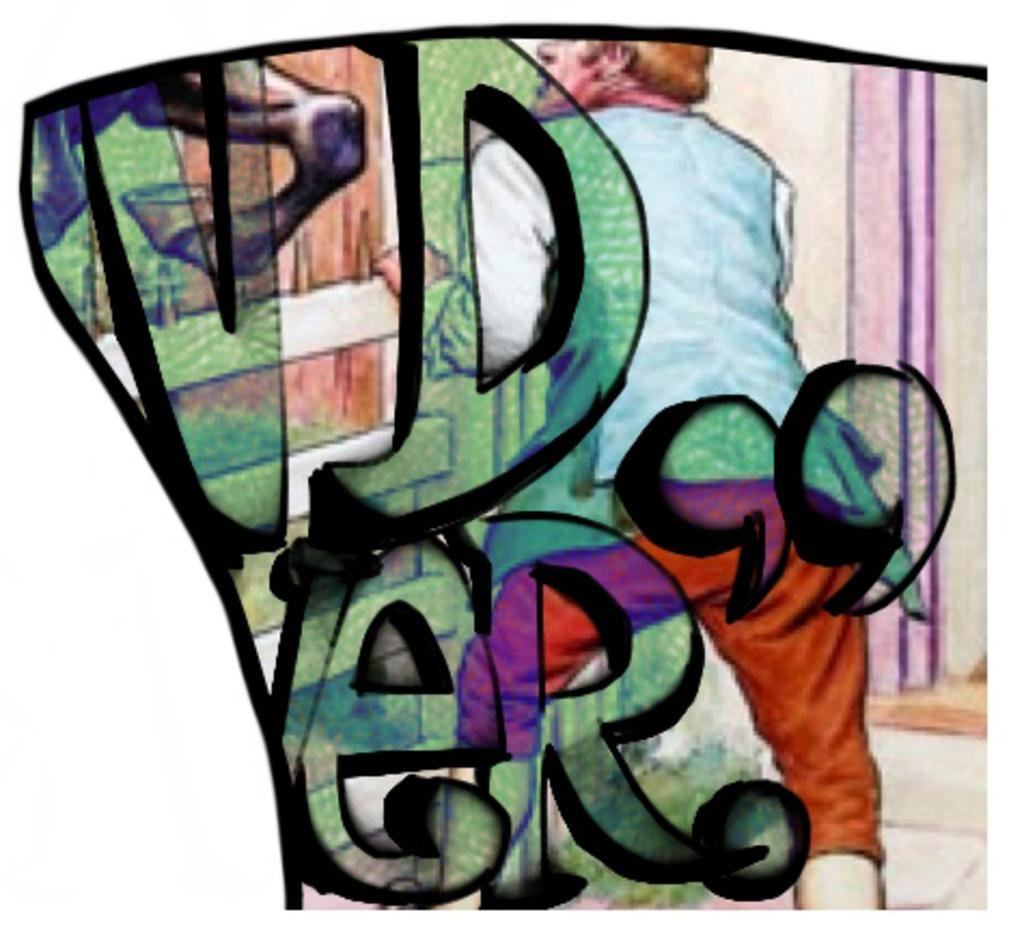What is the main subject of the image? There is a depiction picture in the image. What can be seen written on the picture? Something is written in the front of the picture. Can you identify any people in the image? Yes, there is a person visible in the picture. What other elements are present in the image? The legs of a horse are present in the image. What type of cow can be seen grazing in the background of the image? There is no cow present in the image; it only features a depiction picture with a person and the legs of a horse. 